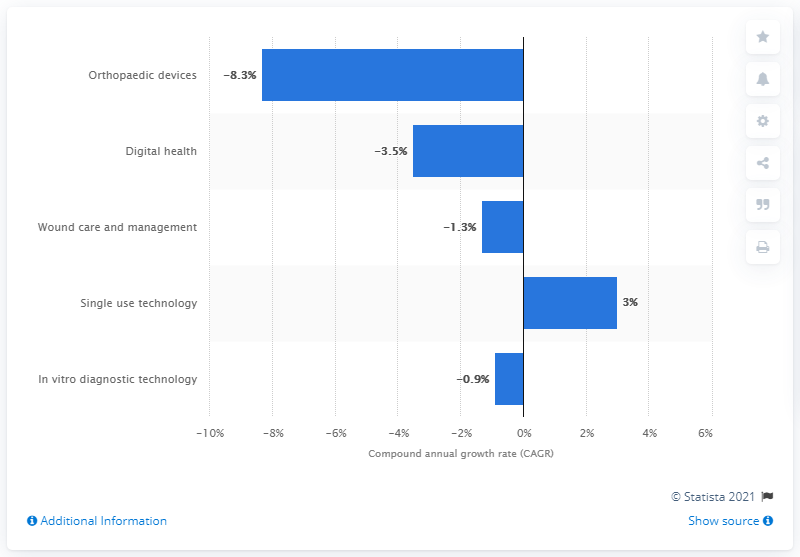Outline some significant characteristics in this image. The single-use technology sector experienced a growth rate of approximately 3% between 2011 and 2016. 